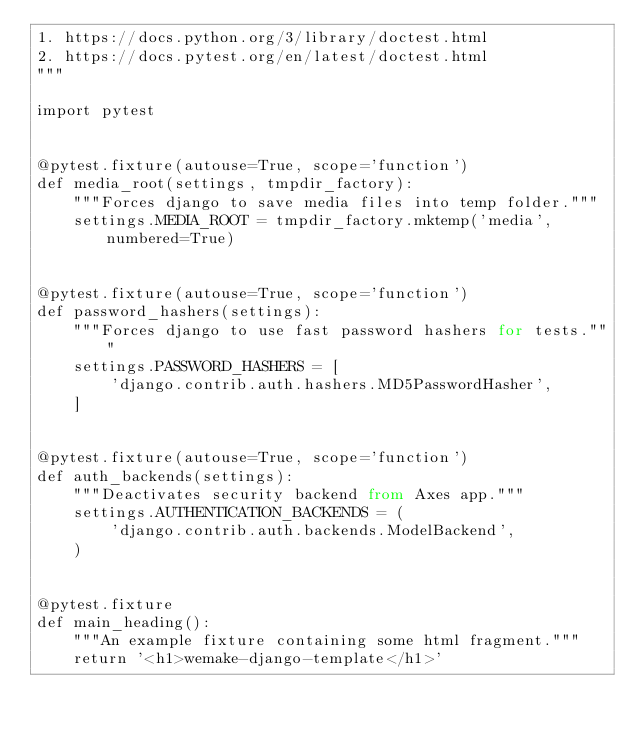Convert code to text. <code><loc_0><loc_0><loc_500><loc_500><_Python_>1. https://docs.python.org/3/library/doctest.html
2. https://docs.pytest.org/en/latest/doctest.html
"""

import pytest


@pytest.fixture(autouse=True, scope='function')
def media_root(settings, tmpdir_factory):
    """Forces django to save media files into temp folder."""
    settings.MEDIA_ROOT = tmpdir_factory.mktemp('media', numbered=True)


@pytest.fixture(autouse=True, scope='function')
def password_hashers(settings):
    """Forces django to use fast password hashers for tests."""
    settings.PASSWORD_HASHERS = [
        'django.contrib.auth.hashers.MD5PasswordHasher',
    ]


@pytest.fixture(autouse=True, scope='function')
def auth_backends(settings):
    """Deactivates security backend from Axes app."""
    settings.AUTHENTICATION_BACKENDS = (
        'django.contrib.auth.backends.ModelBackend',
    )


@pytest.fixture
def main_heading():
    """An example fixture containing some html fragment."""
    return '<h1>wemake-django-template</h1>'
</code> 